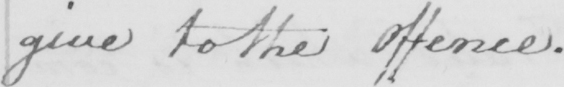Transcribe the text shown in this historical manuscript line. give to the Offence . 